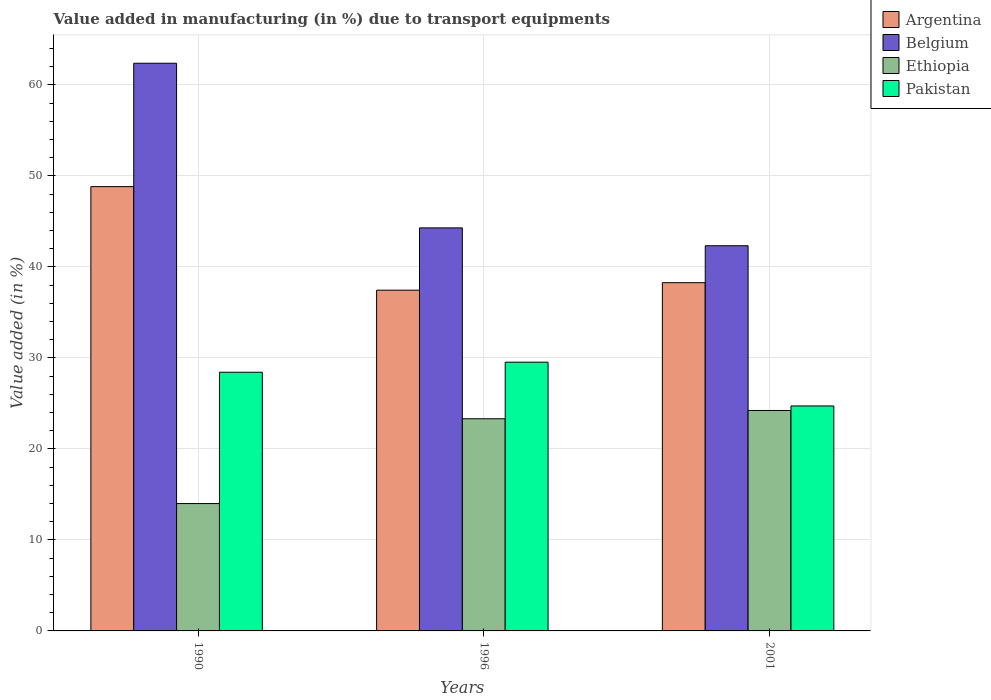How many groups of bars are there?
Provide a succinct answer. 3. Are the number of bars on each tick of the X-axis equal?
Give a very brief answer. Yes. How many bars are there on the 2nd tick from the left?
Keep it short and to the point. 4. What is the label of the 3rd group of bars from the left?
Offer a terse response. 2001. What is the percentage of value added in manufacturing due to transport equipments in Ethiopia in 1990?
Your answer should be compact. 14. Across all years, what is the maximum percentage of value added in manufacturing due to transport equipments in Pakistan?
Your response must be concise. 29.53. Across all years, what is the minimum percentage of value added in manufacturing due to transport equipments in Belgium?
Offer a terse response. 42.32. In which year was the percentage of value added in manufacturing due to transport equipments in Pakistan minimum?
Give a very brief answer. 2001. What is the total percentage of value added in manufacturing due to transport equipments in Belgium in the graph?
Your answer should be very brief. 148.99. What is the difference between the percentage of value added in manufacturing due to transport equipments in Pakistan in 1990 and that in 2001?
Ensure brevity in your answer.  3.71. What is the difference between the percentage of value added in manufacturing due to transport equipments in Pakistan in 1996 and the percentage of value added in manufacturing due to transport equipments in Argentina in 1990?
Your answer should be very brief. -19.29. What is the average percentage of value added in manufacturing due to transport equipments in Belgium per year?
Make the answer very short. 49.66. In the year 1990, what is the difference between the percentage of value added in manufacturing due to transport equipments in Ethiopia and percentage of value added in manufacturing due to transport equipments in Pakistan?
Offer a terse response. -14.43. In how many years, is the percentage of value added in manufacturing due to transport equipments in Argentina greater than 62 %?
Your answer should be compact. 0. What is the ratio of the percentage of value added in manufacturing due to transport equipments in Pakistan in 1996 to that in 2001?
Keep it short and to the point. 1.19. Is the percentage of value added in manufacturing due to transport equipments in Ethiopia in 1996 less than that in 2001?
Your answer should be very brief. Yes. Is the difference between the percentage of value added in manufacturing due to transport equipments in Ethiopia in 1990 and 2001 greater than the difference between the percentage of value added in manufacturing due to transport equipments in Pakistan in 1990 and 2001?
Keep it short and to the point. No. What is the difference between the highest and the second highest percentage of value added in manufacturing due to transport equipments in Belgium?
Your answer should be very brief. 18.09. What is the difference between the highest and the lowest percentage of value added in manufacturing due to transport equipments in Pakistan?
Give a very brief answer. 4.81. What does the 2nd bar from the left in 2001 represents?
Ensure brevity in your answer.  Belgium. What does the 2nd bar from the right in 2001 represents?
Offer a terse response. Ethiopia. Are all the bars in the graph horizontal?
Provide a succinct answer. No. Does the graph contain any zero values?
Your response must be concise. No. Does the graph contain grids?
Your answer should be very brief. Yes. Where does the legend appear in the graph?
Provide a short and direct response. Top right. How many legend labels are there?
Your response must be concise. 4. How are the legend labels stacked?
Offer a very short reply. Vertical. What is the title of the graph?
Give a very brief answer. Value added in manufacturing (in %) due to transport equipments. Does "Paraguay" appear as one of the legend labels in the graph?
Offer a terse response. No. What is the label or title of the X-axis?
Offer a terse response. Years. What is the label or title of the Y-axis?
Your answer should be compact. Value added (in %). What is the Value added (in %) of Argentina in 1990?
Make the answer very short. 48.82. What is the Value added (in %) in Belgium in 1990?
Your response must be concise. 62.38. What is the Value added (in %) in Ethiopia in 1990?
Give a very brief answer. 14. What is the Value added (in %) in Pakistan in 1990?
Make the answer very short. 28.42. What is the Value added (in %) in Argentina in 1996?
Make the answer very short. 37.44. What is the Value added (in %) in Belgium in 1996?
Your response must be concise. 44.29. What is the Value added (in %) in Ethiopia in 1996?
Keep it short and to the point. 23.31. What is the Value added (in %) of Pakistan in 1996?
Offer a terse response. 29.53. What is the Value added (in %) of Argentina in 2001?
Ensure brevity in your answer.  38.26. What is the Value added (in %) in Belgium in 2001?
Make the answer very short. 42.32. What is the Value added (in %) of Ethiopia in 2001?
Provide a short and direct response. 24.22. What is the Value added (in %) in Pakistan in 2001?
Your answer should be compact. 24.72. Across all years, what is the maximum Value added (in %) in Argentina?
Provide a short and direct response. 48.82. Across all years, what is the maximum Value added (in %) in Belgium?
Offer a very short reply. 62.38. Across all years, what is the maximum Value added (in %) in Ethiopia?
Keep it short and to the point. 24.22. Across all years, what is the maximum Value added (in %) in Pakistan?
Your response must be concise. 29.53. Across all years, what is the minimum Value added (in %) of Argentina?
Your answer should be very brief. 37.44. Across all years, what is the minimum Value added (in %) in Belgium?
Ensure brevity in your answer.  42.32. Across all years, what is the minimum Value added (in %) in Ethiopia?
Give a very brief answer. 14. Across all years, what is the minimum Value added (in %) of Pakistan?
Your response must be concise. 24.72. What is the total Value added (in %) in Argentina in the graph?
Provide a short and direct response. 124.53. What is the total Value added (in %) in Belgium in the graph?
Ensure brevity in your answer.  148.99. What is the total Value added (in %) in Ethiopia in the graph?
Offer a very short reply. 61.53. What is the total Value added (in %) in Pakistan in the graph?
Your answer should be very brief. 82.67. What is the difference between the Value added (in %) in Argentina in 1990 and that in 1996?
Provide a short and direct response. 11.38. What is the difference between the Value added (in %) of Belgium in 1990 and that in 1996?
Offer a terse response. 18.09. What is the difference between the Value added (in %) of Ethiopia in 1990 and that in 1996?
Offer a terse response. -9.32. What is the difference between the Value added (in %) in Pakistan in 1990 and that in 1996?
Your answer should be very brief. -1.11. What is the difference between the Value added (in %) in Argentina in 1990 and that in 2001?
Provide a short and direct response. 10.56. What is the difference between the Value added (in %) of Belgium in 1990 and that in 2001?
Your answer should be compact. 20.05. What is the difference between the Value added (in %) in Ethiopia in 1990 and that in 2001?
Provide a succinct answer. -10.23. What is the difference between the Value added (in %) of Pakistan in 1990 and that in 2001?
Make the answer very short. 3.71. What is the difference between the Value added (in %) in Argentina in 1996 and that in 2001?
Your answer should be compact. -0.82. What is the difference between the Value added (in %) in Belgium in 1996 and that in 2001?
Make the answer very short. 1.96. What is the difference between the Value added (in %) in Ethiopia in 1996 and that in 2001?
Your answer should be very brief. -0.91. What is the difference between the Value added (in %) in Pakistan in 1996 and that in 2001?
Provide a short and direct response. 4.81. What is the difference between the Value added (in %) in Argentina in 1990 and the Value added (in %) in Belgium in 1996?
Offer a terse response. 4.53. What is the difference between the Value added (in %) in Argentina in 1990 and the Value added (in %) in Ethiopia in 1996?
Keep it short and to the point. 25.51. What is the difference between the Value added (in %) in Argentina in 1990 and the Value added (in %) in Pakistan in 1996?
Your answer should be compact. 19.29. What is the difference between the Value added (in %) of Belgium in 1990 and the Value added (in %) of Ethiopia in 1996?
Give a very brief answer. 39.06. What is the difference between the Value added (in %) of Belgium in 1990 and the Value added (in %) of Pakistan in 1996?
Offer a very short reply. 32.85. What is the difference between the Value added (in %) in Ethiopia in 1990 and the Value added (in %) in Pakistan in 1996?
Your response must be concise. -15.53. What is the difference between the Value added (in %) in Argentina in 1990 and the Value added (in %) in Belgium in 2001?
Offer a terse response. 6.5. What is the difference between the Value added (in %) of Argentina in 1990 and the Value added (in %) of Ethiopia in 2001?
Offer a terse response. 24.6. What is the difference between the Value added (in %) in Argentina in 1990 and the Value added (in %) in Pakistan in 2001?
Give a very brief answer. 24.1. What is the difference between the Value added (in %) of Belgium in 1990 and the Value added (in %) of Ethiopia in 2001?
Your answer should be compact. 38.15. What is the difference between the Value added (in %) of Belgium in 1990 and the Value added (in %) of Pakistan in 2001?
Make the answer very short. 37.66. What is the difference between the Value added (in %) of Ethiopia in 1990 and the Value added (in %) of Pakistan in 2001?
Offer a terse response. -10.72. What is the difference between the Value added (in %) in Argentina in 1996 and the Value added (in %) in Belgium in 2001?
Make the answer very short. -4.88. What is the difference between the Value added (in %) of Argentina in 1996 and the Value added (in %) of Ethiopia in 2001?
Your answer should be compact. 13.22. What is the difference between the Value added (in %) in Argentina in 1996 and the Value added (in %) in Pakistan in 2001?
Provide a succinct answer. 12.72. What is the difference between the Value added (in %) in Belgium in 1996 and the Value added (in %) in Ethiopia in 2001?
Your answer should be very brief. 20.07. What is the difference between the Value added (in %) in Belgium in 1996 and the Value added (in %) in Pakistan in 2001?
Keep it short and to the point. 19.57. What is the difference between the Value added (in %) of Ethiopia in 1996 and the Value added (in %) of Pakistan in 2001?
Provide a succinct answer. -1.41. What is the average Value added (in %) in Argentina per year?
Provide a short and direct response. 41.51. What is the average Value added (in %) of Belgium per year?
Make the answer very short. 49.66. What is the average Value added (in %) of Ethiopia per year?
Ensure brevity in your answer.  20.51. What is the average Value added (in %) in Pakistan per year?
Give a very brief answer. 27.56. In the year 1990, what is the difference between the Value added (in %) of Argentina and Value added (in %) of Belgium?
Offer a very short reply. -13.56. In the year 1990, what is the difference between the Value added (in %) of Argentina and Value added (in %) of Ethiopia?
Your answer should be compact. 34.82. In the year 1990, what is the difference between the Value added (in %) in Argentina and Value added (in %) in Pakistan?
Ensure brevity in your answer.  20.4. In the year 1990, what is the difference between the Value added (in %) of Belgium and Value added (in %) of Ethiopia?
Your response must be concise. 48.38. In the year 1990, what is the difference between the Value added (in %) in Belgium and Value added (in %) in Pakistan?
Your response must be concise. 33.95. In the year 1990, what is the difference between the Value added (in %) of Ethiopia and Value added (in %) of Pakistan?
Provide a short and direct response. -14.43. In the year 1996, what is the difference between the Value added (in %) of Argentina and Value added (in %) of Belgium?
Provide a succinct answer. -6.84. In the year 1996, what is the difference between the Value added (in %) of Argentina and Value added (in %) of Ethiopia?
Your answer should be very brief. 14.13. In the year 1996, what is the difference between the Value added (in %) in Argentina and Value added (in %) in Pakistan?
Your answer should be compact. 7.91. In the year 1996, what is the difference between the Value added (in %) of Belgium and Value added (in %) of Ethiopia?
Ensure brevity in your answer.  20.97. In the year 1996, what is the difference between the Value added (in %) in Belgium and Value added (in %) in Pakistan?
Ensure brevity in your answer.  14.76. In the year 1996, what is the difference between the Value added (in %) of Ethiopia and Value added (in %) of Pakistan?
Your answer should be very brief. -6.22. In the year 2001, what is the difference between the Value added (in %) in Argentina and Value added (in %) in Belgium?
Offer a terse response. -4.06. In the year 2001, what is the difference between the Value added (in %) in Argentina and Value added (in %) in Ethiopia?
Make the answer very short. 14.04. In the year 2001, what is the difference between the Value added (in %) in Argentina and Value added (in %) in Pakistan?
Offer a terse response. 13.55. In the year 2001, what is the difference between the Value added (in %) in Belgium and Value added (in %) in Ethiopia?
Your answer should be very brief. 18.1. In the year 2001, what is the difference between the Value added (in %) in Belgium and Value added (in %) in Pakistan?
Provide a short and direct response. 17.61. In the year 2001, what is the difference between the Value added (in %) of Ethiopia and Value added (in %) of Pakistan?
Keep it short and to the point. -0.5. What is the ratio of the Value added (in %) of Argentina in 1990 to that in 1996?
Give a very brief answer. 1.3. What is the ratio of the Value added (in %) of Belgium in 1990 to that in 1996?
Make the answer very short. 1.41. What is the ratio of the Value added (in %) in Ethiopia in 1990 to that in 1996?
Offer a very short reply. 0.6. What is the ratio of the Value added (in %) in Pakistan in 1990 to that in 1996?
Your answer should be very brief. 0.96. What is the ratio of the Value added (in %) of Argentina in 1990 to that in 2001?
Ensure brevity in your answer.  1.28. What is the ratio of the Value added (in %) of Belgium in 1990 to that in 2001?
Your answer should be very brief. 1.47. What is the ratio of the Value added (in %) in Ethiopia in 1990 to that in 2001?
Keep it short and to the point. 0.58. What is the ratio of the Value added (in %) of Pakistan in 1990 to that in 2001?
Provide a succinct answer. 1.15. What is the ratio of the Value added (in %) of Argentina in 1996 to that in 2001?
Ensure brevity in your answer.  0.98. What is the ratio of the Value added (in %) of Belgium in 1996 to that in 2001?
Offer a terse response. 1.05. What is the ratio of the Value added (in %) of Ethiopia in 1996 to that in 2001?
Give a very brief answer. 0.96. What is the ratio of the Value added (in %) in Pakistan in 1996 to that in 2001?
Give a very brief answer. 1.19. What is the difference between the highest and the second highest Value added (in %) in Argentina?
Your answer should be compact. 10.56. What is the difference between the highest and the second highest Value added (in %) in Belgium?
Ensure brevity in your answer.  18.09. What is the difference between the highest and the second highest Value added (in %) in Ethiopia?
Make the answer very short. 0.91. What is the difference between the highest and the second highest Value added (in %) in Pakistan?
Provide a short and direct response. 1.11. What is the difference between the highest and the lowest Value added (in %) in Argentina?
Your answer should be very brief. 11.38. What is the difference between the highest and the lowest Value added (in %) in Belgium?
Give a very brief answer. 20.05. What is the difference between the highest and the lowest Value added (in %) of Ethiopia?
Provide a short and direct response. 10.23. What is the difference between the highest and the lowest Value added (in %) of Pakistan?
Your answer should be very brief. 4.81. 